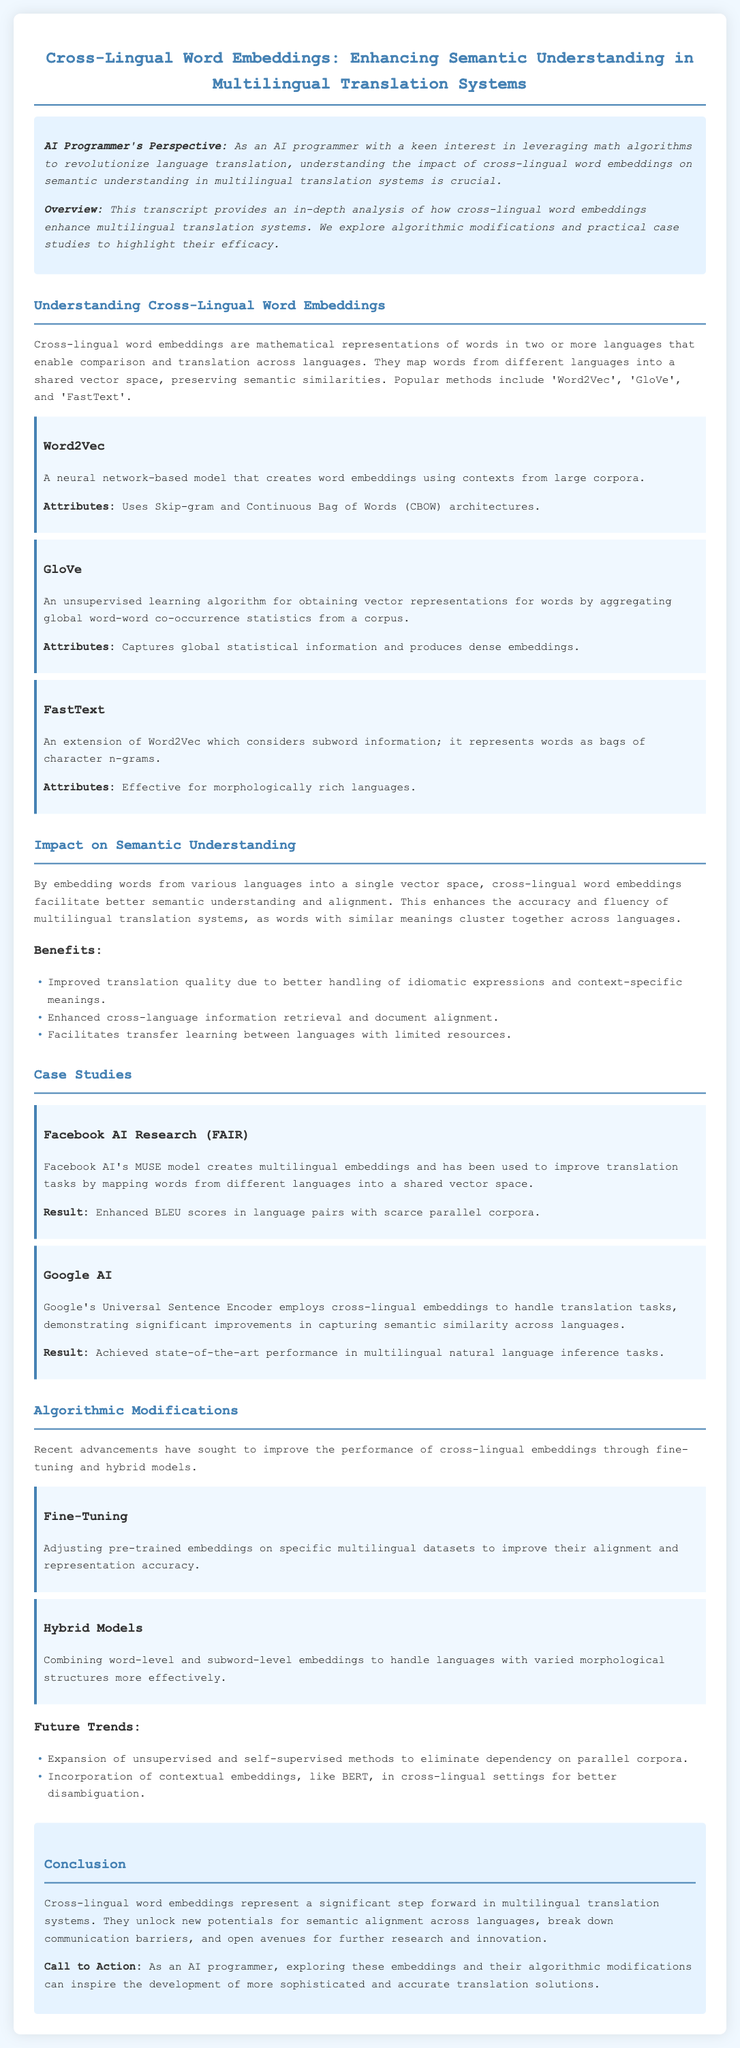What are cross-lingual word embeddings? Cross-lingual word embeddings are mathematical representations of words in two or more languages that enable comparison and translation across languages.
Answer: Mathematical representations What are the three popular methods of cross-lingual word embeddings? The document lists Word2Vec, GloVe, and FastText as popular methods.
Answer: Word2Vec, GloVe, FastText What is the result of Facebook AI's MUSE model? The result from the MUSE model is enhanced BLEU scores in language pairs with scarce parallel corpora.
Answer: Enhanced BLEU scores What type of embeddings does Google's Universal Sentence Encoder use? The Universal Sentence Encoder employs cross-lingual embeddings to handle translation tasks.
Answer: Cross-lingual embeddings What recent advancement improves alignment and representation accuracy of embeddings? Fine-tuning has been identified as an advancement to improve alignment and representation accuracy.
Answer: Fine-tuning What is the primary focus of the document? The document primarily focuses on analyzing the impact of cross-lingual word embeddings on semantic understanding in multilingual translation systems.
Answer: Impact on semantic understanding How do cross-lingual word embeddings enhance translation quality? They improve translation quality by better handling idiomatic expressions and context-specific meanings.
Answer: Better handling of idiomatic expressions What does the conclusion emphasize about further research? The conclusion emphasizes exploring these embeddings and their algorithmic modifications for more sophisticated translation solutions.
Answer: Exploring these embeddings What two future trends are mentioned regarding embeddings? The future trends mentioned include expansion of unsupervised methods and incorporation of contextual embeddings.
Answer: Expansion of unsupervised methods, incorporation of contextual embeddings 